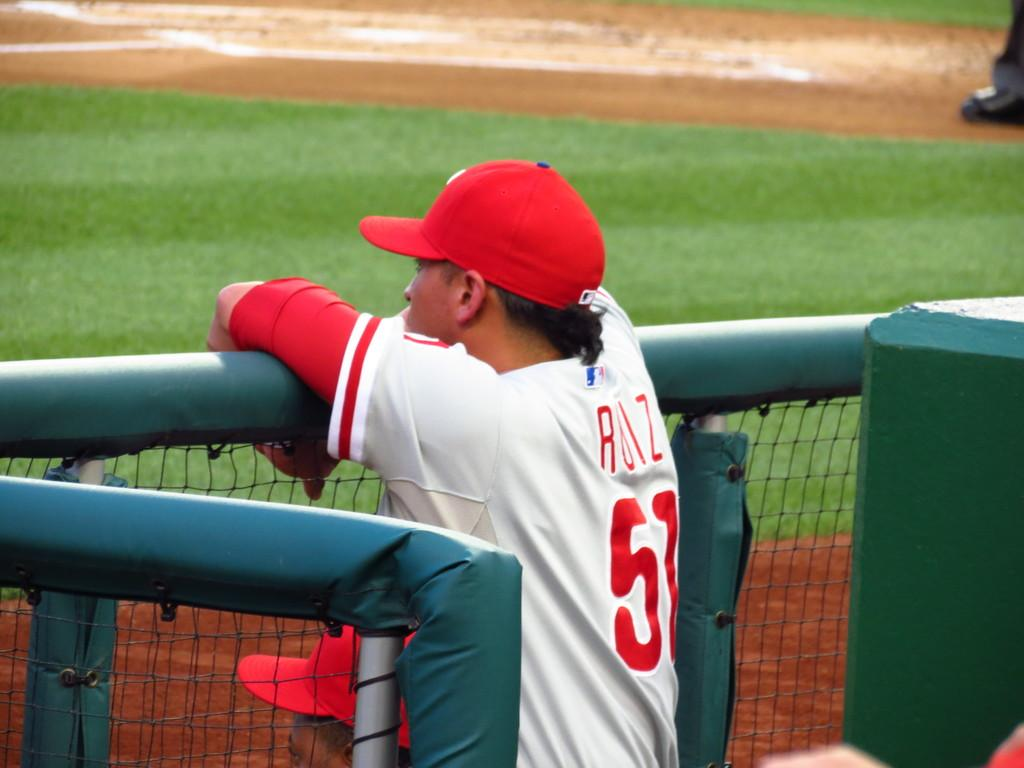Provide a one-sentence caption for the provided image. A baseball player who's name starts with an R, watching the basebell field from the dugout. 